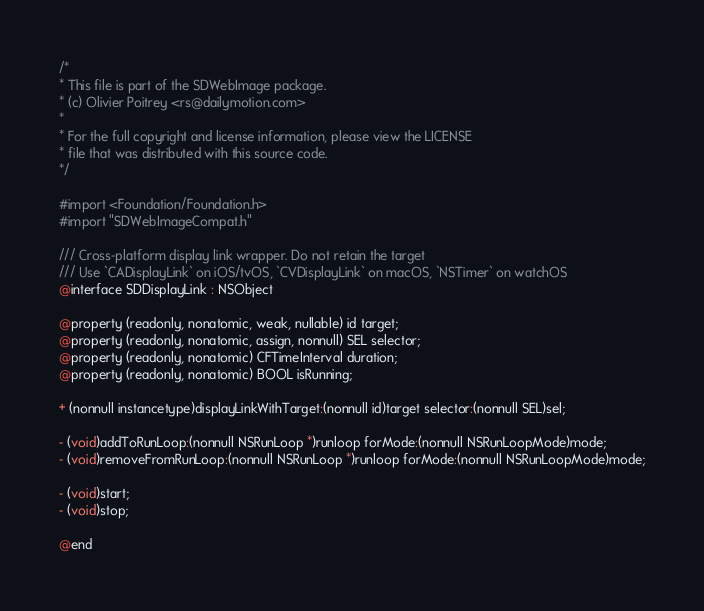Convert code to text. <code><loc_0><loc_0><loc_500><loc_500><_C_>/*
* This file is part of the SDWebImage package.
* (c) Olivier Poitrey <rs@dailymotion.com>
*
* For the full copyright and license information, please view the LICENSE
* file that was distributed with this source code.
*/

#import <Foundation/Foundation.h>
#import "SDWebImageCompat.h"

/// Cross-platform display link wrapper. Do not retain the target
/// Use `CADisplayLink` on iOS/tvOS, `CVDisplayLink` on macOS, `NSTimer` on watchOS
@interface SDDisplayLink : NSObject

@property (readonly, nonatomic, weak, nullable) id target;
@property (readonly, nonatomic, assign, nonnull) SEL selector;
@property (readonly, nonatomic) CFTimeInterval duration;
@property (readonly, nonatomic) BOOL isRunning;

+ (nonnull instancetype)displayLinkWithTarget:(nonnull id)target selector:(nonnull SEL)sel;

- (void)addToRunLoop:(nonnull NSRunLoop *)runloop forMode:(nonnull NSRunLoopMode)mode;
- (void)removeFromRunLoop:(nonnull NSRunLoop *)runloop forMode:(nonnull NSRunLoopMode)mode;

- (void)start;
- (void)stop;

@end
</code> 